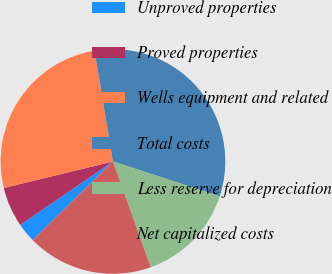Convert chart. <chart><loc_0><loc_0><loc_500><loc_500><pie_chart><fcel>Unproved properties<fcel>Proved properties<fcel>Wells equipment and related<fcel>Total costs<fcel>Less reserve for depreciation<fcel>Net capitalized costs<nl><fcel>2.78%<fcel>5.76%<fcel>26.17%<fcel>32.64%<fcel>14.52%<fcel>18.12%<nl></chart> 